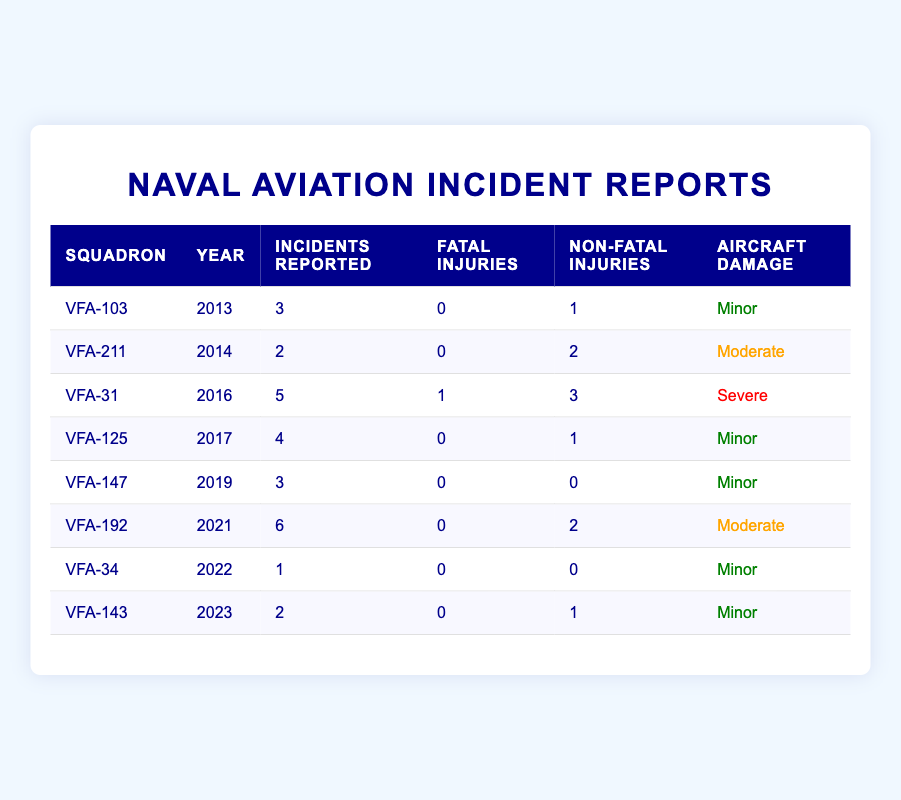What is the total number of incidents reported across all squadrons from 2013 to 2023? To find the total number of incidents reported, we need to sum the "incidents reported" column for each year from 2013 to 2023: 3 + 2 + 5 + 4 + 3 + 6 + 1 + 2 = 26.
Answer: 26 Which squadron reported the highest number of non-fatal injuries? Looking at the "non-fatal injuries" column, VFA-31 has 3 non-fatal injuries in 2016, which is the highest among all squadrons.
Answer: VFA-31 Did any squadron report fatal injuries in the year 2016? The table shows that VFA-31 reported 1 fatal injury in 2016, making it true that a squadron reported fatal injuries that year.
Answer: Yes What is the average number of incidents reported per year from 2013 to 2023? The total incidents reported is 26 (calculated earlier). There are 8 data points (years), so the average is 26 / 8 = 3.25.
Answer: 3.25 In which years did squadrons report minor aircraft damage? By checking the "aircraft damage" column, we find that minor damage was reported in 2013 (VFA-103), 2017 (VFA-125), 2019 (VFA-147), 2022 (VFA-34), and 2023 (VFA-143).
Answer: 2013, 2017, 2019, 2022, 2023 How many squadrons reported incidents with moderate aircraft damage? By looking at the "aircraft damage" column, we find that VFA-211 (2014) and VFA-192 (2021) reported moderate damage, totaling 2 squadrons.
Answer: 2 Which year had the most reported incidents, and how many were there? The year with the most incidents is 2021, with 6 reported incidents by VFA-192.
Answer: 2021, 6 Were there any years without reported incidents? Checking the "incidents reported" column, all years have incidents reported, so the answer is no.
Answer: No What percentage of incidents resulted in fatal injuries? We have a total of 26 incidents and 1 fatal injury in 2016. The percentage is (1 / 26) * 100 = 3.85%.
Answer: 3.85% 